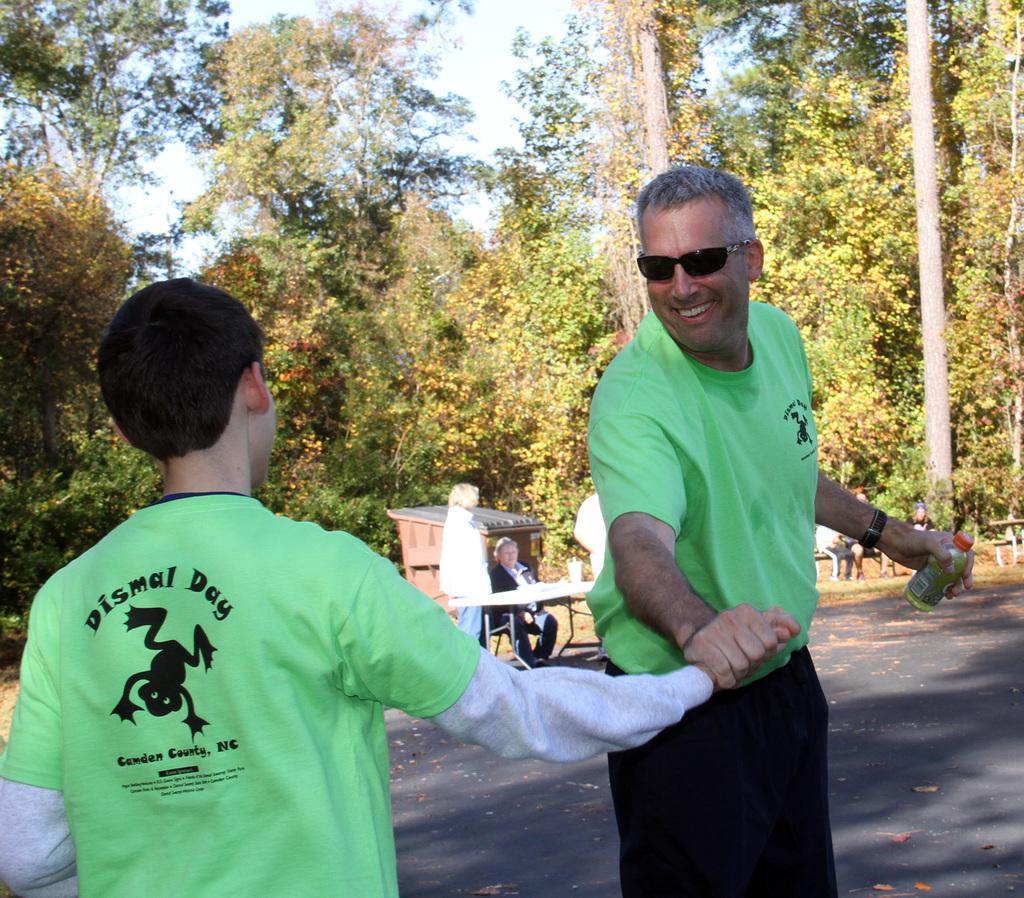Could you give a brief overview of what you see in this image? In this picture we can see two persons are standing in the front, we can see a person is sitting in front of the table, in the background there are some trees, we can see the sky at the top of the picture, on the right side there are some people sitting on a bench. 